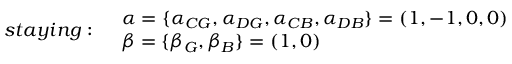Convert formula to latex. <formula><loc_0><loc_0><loc_500><loc_500>\begin{array} { l l } { s t a y i n g \colon } & { \begin{array} { l } { \alpha = \{ \alpha _ { C G } , \alpha _ { D G } , \alpha _ { C B } , \alpha _ { D B } \} = ( 1 , - 1 , 0 , 0 ) } \\ { \beta = \{ \beta _ { G } , \beta _ { B } \} = ( 1 , 0 ) } \end{array} } \end{array}</formula> 